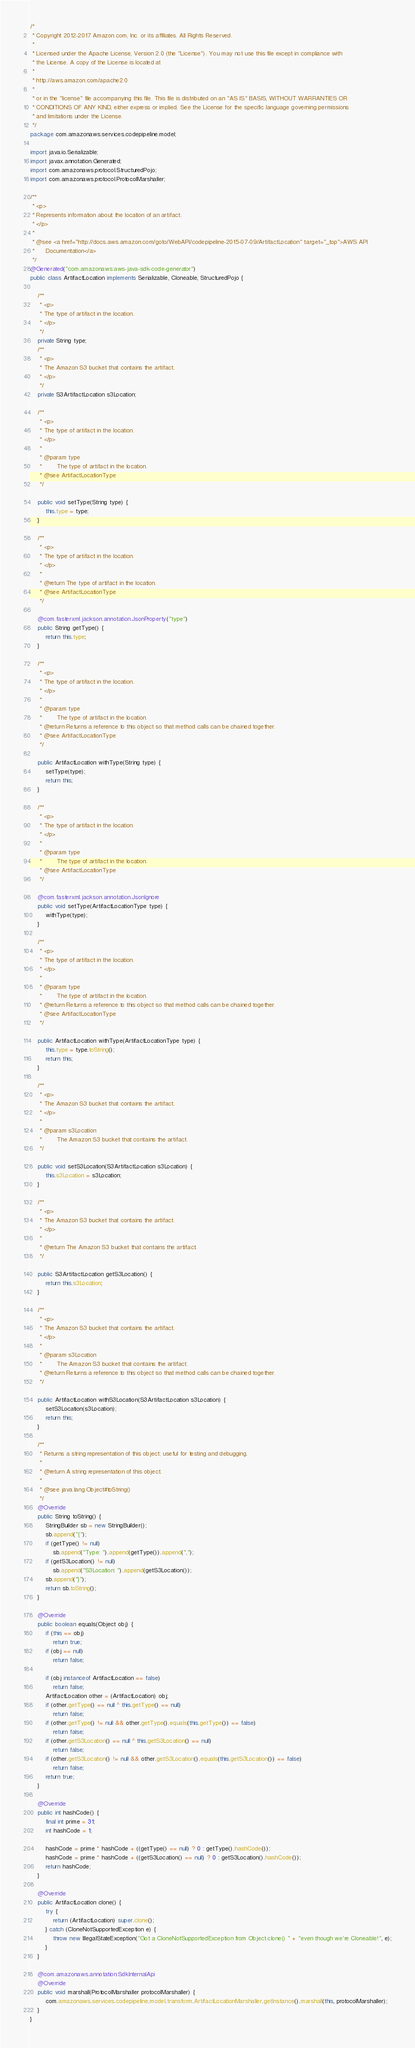Convert code to text. <code><loc_0><loc_0><loc_500><loc_500><_Java_>/*
 * Copyright 2012-2017 Amazon.com, Inc. or its affiliates. All Rights Reserved.
 * 
 * Licensed under the Apache License, Version 2.0 (the "License"). You may not use this file except in compliance with
 * the License. A copy of the License is located at
 * 
 * http://aws.amazon.com/apache2.0
 * 
 * or in the "license" file accompanying this file. This file is distributed on an "AS IS" BASIS, WITHOUT WARRANTIES OR
 * CONDITIONS OF ANY KIND, either express or implied. See the License for the specific language governing permissions
 * and limitations under the License.
 */
package com.amazonaws.services.codepipeline.model;

import java.io.Serializable;
import javax.annotation.Generated;
import com.amazonaws.protocol.StructuredPojo;
import com.amazonaws.protocol.ProtocolMarshaller;

/**
 * <p>
 * Represents information about the location of an artifact.
 * </p>
 * 
 * @see <a href="http://docs.aws.amazon.com/goto/WebAPI/codepipeline-2015-07-09/ArtifactLocation" target="_top">AWS API
 *      Documentation</a>
 */
@Generated("com.amazonaws:aws-java-sdk-code-generator")
public class ArtifactLocation implements Serializable, Cloneable, StructuredPojo {

    /**
     * <p>
     * The type of artifact in the location.
     * </p>
     */
    private String type;
    /**
     * <p>
     * The Amazon S3 bucket that contains the artifact.
     * </p>
     */
    private S3ArtifactLocation s3Location;

    /**
     * <p>
     * The type of artifact in the location.
     * </p>
     * 
     * @param type
     *        The type of artifact in the location.
     * @see ArtifactLocationType
     */

    public void setType(String type) {
        this.type = type;
    }

    /**
     * <p>
     * The type of artifact in the location.
     * </p>
     * 
     * @return The type of artifact in the location.
     * @see ArtifactLocationType
     */

    @com.fasterxml.jackson.annotation.JsonProperty("type")
    public String getType() {
        return this.type;
    }

    /**
     * <p>
     * The type of artifact in the location.
     * </p>
     * 
     * @param type
     *        The type of artifact in the location.
     * @return Returns a reference to this object so that method calls can be chained together.
     * @see ArtifactLocationType
     */

    public ArtifactLocation withType(String type) {
        setType(type);
        return this;
    }

    /**
     * <p>
     * The type of artifact in the location.
     * </p>
     * 
     * @param type
     *        The type of artifact in the location.
     * @see ArtifactLocationType
     */

    @com.fasterxml.jackson.annotation.JsonIgnore
    public void setType(ArtifactLocationType type) {
        withType(type);
    }

    /**
     * <p>
     * The type of artifact in the location.
     * </p>
     * 
     * @param type
     *        The type of artifact in the location.
     * @return Returns a reference to this object so that method calls can be chained together.
     * @see ArtifactLocationType
     */

    public ArtifactLocation withType(ArtifactLocationType type) {
        this.type = type.toString();
        return this;
    }

    /**
     * <p>
     * The Amazon S3 bucket that contains the artifact.
     * </p>
     * 
     * @param s3Location
     *        The Amazon S3 bucket that contains the artifact.
     */

    public void setS3Location(S3ArtifactLocation s3Location) {
        this.s3Location = s3Location;
    }

    /**
     * <p>
     * The Amazon S3 bucket that contains the artifact.
     * </p>
     * 
     * @return The Amazon S3 bucket that contains the artifact.
     */

    public S3ArtifactLocation getS3Location() {
        return this.s3Location;
    }

    /**
     * <p>
     * The Amazon S3 bucket that contains the artifact.
     * </p>
     * 
     * @param s3Location
     *        The Amazon S3 bucket that contains the artifact.
     * @return Returns a reference to this object so that method calls can be chained together.
     */

    public ArtifactLocation withS3Location(S3ArtifactLocation s3Location) {
        setS3Location(s3Location);
        return this;
    }

    /**
     * Returns a string representation of this object; useful for testing and debugging.
     *
     * @return A string representation of this object.
     *
     * @see java.lang.Object#toString()
     */
    @Override
    public String toString() {
        StringBuilder sb = new StringBuilder();
        sb.append("{");
        if (getType() != null)
            sb.append("Type: ").append(getType()).append(",");
        if (getS3Location() != null)
            sb.append("S3Location: ").append(getS3Location());
        sb.append("}");
        return sb.toString();
    }

    @Override
    public boolean equals(Object obj) {
        if (this == obj)
            return true;
        if (obj == null)
            return false;

        if (obj instanceof ArtifactLocation == false)
            return false;
        ArtifactLocation other = (ArtifactLocation) obj;
        if (other.getType() == null ^ this.getType() == null)
            return false;
        if (other.getType() != null && other.getType().equals(this.getType()) == false)
            return false;
        if (other.getS3Location() == null ^ this.getS3Location() == null)
            return false;
        if (other.getS3Location() != null && other.getS3Location().equals(this.getS3Location()) == false)
            return false;
        return true;
    }

    @Override
    public int hashCode() {
        final int prime = 31;
        int hashCode = 1;

        hashCode = prime * hashCode + ((getType() == null) ? 0 : getType().hashCode());
        hashCode = prime * hashCode + ((getS3Location() == null) ? 0 : getS3Location().hashCode());
        return hashCode;
    }

    @Override
    public ArtifactLocation clone() {
        try {
            return (ArtifactLocation) super.clone();
        } catch (CloneNotSupportedException e) {
            throw new IllegalStateException("Got a CloneNotSupportedException from Object.clone() " + "even though we're Cloneable!", e);
        }
    }

    @com.amazonaws.annotation.SdkInternalApi
    @Override
    public void marshall(ProtocolMarshaller protocolMarshaller) {
        com.amazonaws.services.codepipeline.model.transform.ArtifactLocationMarshaller.getInstance().marshall(this, protocolMarshaller);
    }
}
</code> 